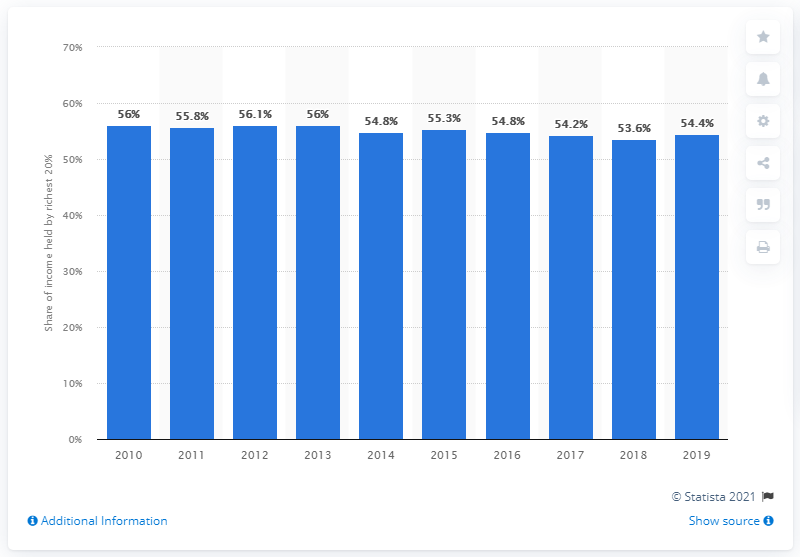Mention a couple of crucial points in this snapshot. The richest 20 percent of Panama's population a year earlier was 53.6 percent. In 2019, the richest 20% of Panama's population held 54.4% of the country's total income. 